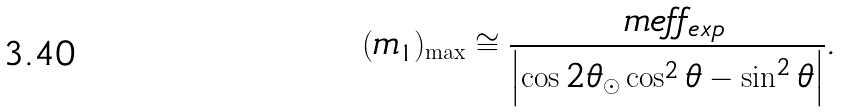Convert formula to latex. <formula><loc_0><loc_0><loc_500><loc_500>( m _ { 1 } ) _ { \max } \cong \frac { \ m e f f _ { e x p } } { \left | \cos 2 \theta _ { \odot } \cos ^ { 2 } \theta - \sin ^ { 2 } \theta \right | } .</formula> 